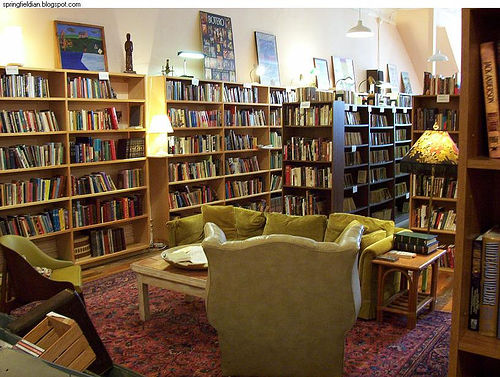<image>
Is there a book on the table? Yes. Looking at the image, I can see the book is positioned on top of the table, with the table providing support. Where is the book in relation to the sofa? Is it on the sofa? No. The book is not positioned on the sofa. They may be near each other, but the book is not supported by or resting on top of the sofa. 